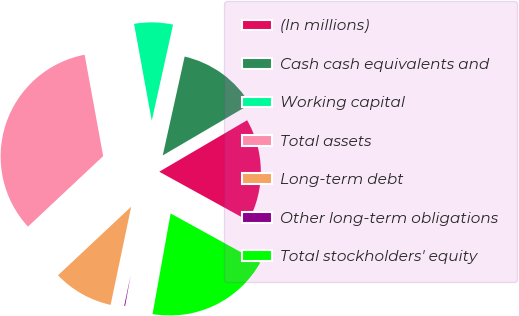Convert chart to OTSL. <chart><loc_0><loc_0><loc_500><loc_500><pie_chart><fcel>(In millions)<fcel>Cash cash equivalents and<fcel>Working capital<fcel>Total assets<fcel>Long-term debt<fcel>Other long-term obligations<fcel>Total stockholders' equity<nl><fcel>16.45%<fcel>13.09%<fcel>6.35%<fcel>34.11%<fcel>9.72%<fcel>0.46%<fcel>19.82%<nl></chart> 